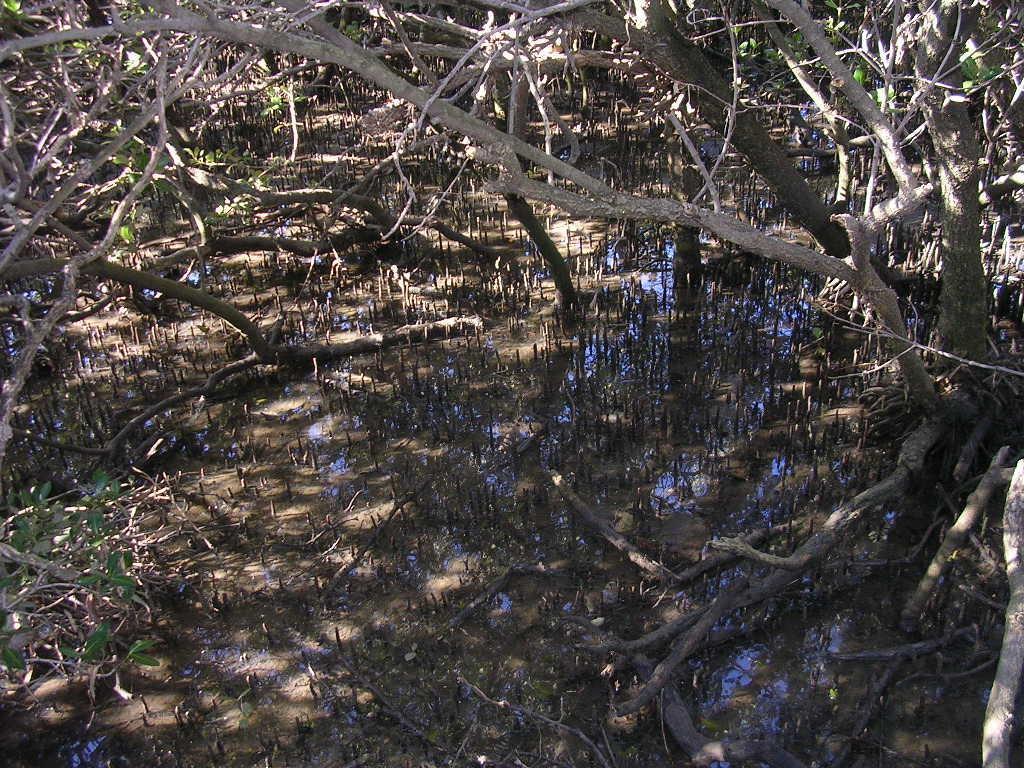How would you summarize this image in a sentence or two? In this image, we can see some trees. We can also see some water with plants. 